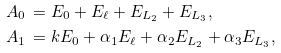<formula> <loc_0><loc_0><loc_500><loc_500>A _ { 0 } & \, = E _ { 0 } + E _ { \ell } + E _ { L _ { 2 } } + E _ { L _ { 3 } } , \\ A _ { 1 } & \, = k E _ { 0 } + \alpha _ { 1 } E _ { \ell } + \alpha _ { 2 } E _ { L _ { 2 } } + \alpha _ { 3 } E _ { L _ { 3 } } ,</formula> 